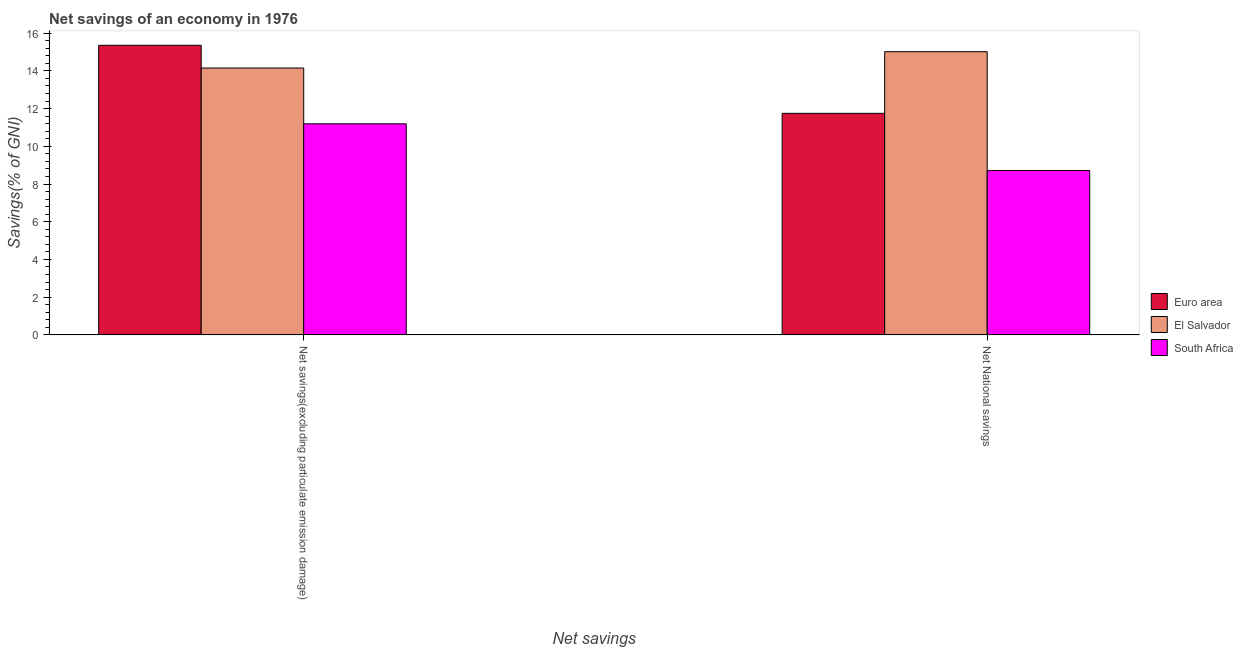How many groups of bars are there?
Make the answer very short. 2. How many bars are there on the 1st tick from the left?
Your answer should be very brief. 3. How many bars are there on the 1st tick from the right?
Make the answer very short. 3. What is the label of the 1st group of bars from the left?
Offer a very short reply. Net savings(excluding particulate emission damage). What is the net savings(excluding particulate emission damage) in El Salvador?
Ensure brevity in your answer.  14.15. Across all countries, what is the maximum net national savings?
Your response must be concise. 15.02. Across all countries, what is the minimum net national savings?
Ensure brevity in your answer.  8.72. In which country was the net national savings maximum?
Provide a succinct answer. El Salvador. In which country was the net savings(excluding particulate emission damage) minimum?
Your answer should be compact. South Africa. What is the total net savings(excluding particulate emission damage) in the graph?
Give a very brief answer. 40.7. What is the difference between the net savings(excluding particulate emission damage) in El Salvador and that in Euro area?
Ensure brevity in your answer.  -1.2. What is the difference between the net national savings in El Salvador and the net savings(excluding particulate emission damage) in South Africa?
Offer a very short reply. 3.82. What is the average net savings(excluding particulate emission damage) per country?
Your answer should be very brief. 13.57. What is the difference between the net national savings and net savings(excluding particulate emission damage) in South Africa?
Make the answer very short. -2.48. What is the ratio of the net national savings in Euro area to that in South Africa?
Offer a very short reply. 1.35. Is the net savings(excluding particulate emission damage) in South Africa less than that in Euro area?
Ensure brevity in your answer.  Yes. In how many countries, is the net national savings greater than the average net national savings taken over all countries?
Offer a terse response. 1. What does the 1st bar from the left in Net savings(excluding particulate emission damage) represents?
Make the answer very short. Euro area. What does the 3rd bar from the right in Net savings(excluding particulate emission damage) represents?
Provide a succinct answer. Euro area. How many bars are there?
Offer a very short reply. 6. How many countries are there in the graph?
Offer a very short reply. 3. What is the difference between two consecutive major ticks on the Y-axis?
Provide a succinct answer. 2. Are the values on the major ticks of Y-axis written in scientific E-notation?
Give a very brief answer. No. Does the graph contain any zero values?
Keep it short and to the point. No. Does the graph contain grids?
Your response must be concise. No. Where does the legend appear in the graph?
Ensure brevity in your answer.  Center right. How many legend labels are there?
Keep it short and to the point. 3. How are the legend labels stacked?
Ensure brevity in your answer.  Vertical. What is the title of the graph?
Offer a very short reply. Net savings of an economy in 1976. Does "Kosovo" appear as one of the legend labels in the graph?
Make the answer very short. No. What is the label or title of the X-axis?
Your answer should be very brief. Net savings. What is the label or title of the Y-axis?
Ensure brevity in your answer.  Savings(% of GNI). What is the Savings(% of GNI) of Euro area in Net savings(excluding particulate emission damage)?
Your answer should be compact. 15.35. What is the Savings(% of GNI) in El Salvador in Net savings(excluding particulate emission damage)?
Your response must be concise. 14.15. What is the Savings(% of GNI) in South Africa in Net savings(excluding particulate emission damage)?
Ensure brevity in your answer.  11.19. What is the Savings(% of GNI) of Euro area in Net National savings?
Ensure brevity in your answer.  11.75. What is the Savings(% of GNI) in El Salvador in Net National savings?
Provide a succinct answer. 15.02. What is the Savings(% of GNI) in South Africa in Net National savings?
Ensure brevity in your answer.  8.72. Across all Net savings, what is the maximum Savings(% of GNI) in Euro area?
Provide a short and direct response. 15.35. Across all Net savings, what is the maximum Savings(% of GNI) of El Salvador?
Your answer should be very brief. 15.02. Across all Net savings, what is the maximum Savings(% of GNI) of South Africa?
Provide a short and direct response. 11.19. Across all Net savings, what is the minimum Savings(% of GNI) of Euro area?
Offer a very short reply. 11.75. Across all Net savings, what is the minimum Savings(% of GNI) in El Salvador?
Keep it short and to the point. 14.15. Across all Net savings, what is the minimum Savings(% of GNI) in South Africa?
Offer a very short reply. 8.72. What is the total Savings(% of GNI) in Euro area in the graph?
Offer a very short reply. 27.1. What is the total Savings(% of GNI) in El Salvador in the graph?
Your answer should be very brief. 29.16. What is the total Savings(% of GNI) of South Africa in the graph?
Give a very brief answer. 19.91. What is the difference between the Savings(% of GNI) in Euro area in Net savings(excluding particulate emission damage) and that in Net National savings?
Offer a very short reply. 3.61. What is the difference between the Savings(% of GNI) of El Salvador in Net savings(excluding particulate emission damage) and that in Net National savings?
Offer a very short reply. -0.87. What is the difference between the Savings(% of GNI) of South Africa in Net savings(excluding particulate emission damage) and that in Net National savings?
Keep it short and to the point. 2.48. What is the difference between the Savings(% of GNI) of Euro area in Net savings(excluding particulate emission damage) and the Savings(% of GNI) of El Salvador in Net National savings?
Ensure brevity in your answer.  0.34. What is the difference between the Savings(% of GNI) of Euro area in Net savings(excluding particulate emission damage) and the Savings(% of GNI) of South Africa in Net National savings?
Give a very brief answer. 6.64. What is the difference between the Savings(% of GNI) of El Salvador in Net savings(excluding particulate emission damage) and the Savings(% of GNI) of South Africa in Net National savings?
Provide a succinct answer. 5.43. What is the average Savings(% of GNI) in Euro area per Net savings?
Ensure brevity in your answer.  13.55. What is the average Savings(% of GNI) of El Salvador per Net savings?
Provide a short and direct response. 14.58. What is the average Savings(% of GNI) of South Africa per Net savings?
Provide a succinct answer. 9.95. What is the difference between the Savings(% of GNI) in Euro area and Savings(% of GNI) in El Salvador in Net savings(excluding particulate emission damage)?
Give a very brief answer. 1.2. What is the difference between the Savings(% of GNI) in Euro area and Savings(% of GNI) in South Africa in Net savings(excluding particulate emission damage)?
Your response must be concise. 4.16. What is the difference between the Savings(% of GNI) in El Salvador and Savings(% of GNI) in South Africa in Net savings(excluding particulate emission damage)?
Offer a terse response. 2.96. What is the difference between the Savings(% of GNI) in Euro area and Savings(% of GNI) in El Salvador in Net National savings?
Give a very brief answer. -3.27. What is the difference between the Savings(% of GNI) of Euro area and Savings(% of GNI) of South Africa in Net National savings?
Your answer should be very brief. 3.03. What is the difference between the Savings(% of GNI) of El Salvador and Savings(% of GNI) of South Africa in Net National savings?
Provide a short and direct response. 6.3. What is the ratio of the Savings(% of GNI) in Euro area in Net savings(excluding particulate emission damage) to that in Net National savings?
Offer a terse response. 1.31. What is the ratio of the Savings(% of GNI) of El Salvador in Net savings(excluding particulate emission damage) to that in Net National savings?
Your answer should be very brief. 0.94. What is the ratio of the Savings(% of GNI) in South Africa in Net savings(excluding particulate emission damage) to that in Net National savings?
Offer a terse response. 1.28. What is the difference between the highest and the second highest Savings(% of GNI) in Euro area?
Your response must be concise. 3.61. What is the difference between the highest and the second highest Savings(% of GNI) of El Salvador?
Keep it short and to the point. 0.87. What is the difference between the highest and the second highest Savings(% of GNI) in South Africa?
Make the answer very short. 2.48. What is the difference between the highest and the lowest Savings(% of GNI) in Euro area?
Keep it short and to the point. 3.61. What is the difference between the highest and the lowest Savings(% of GNI) of El Salvador?
Keep it short and to the point. 0.87. What is the difference between the highest and the lowest Savings(% of GNI) in South Africa?
Make the answer very short. 2.48. 